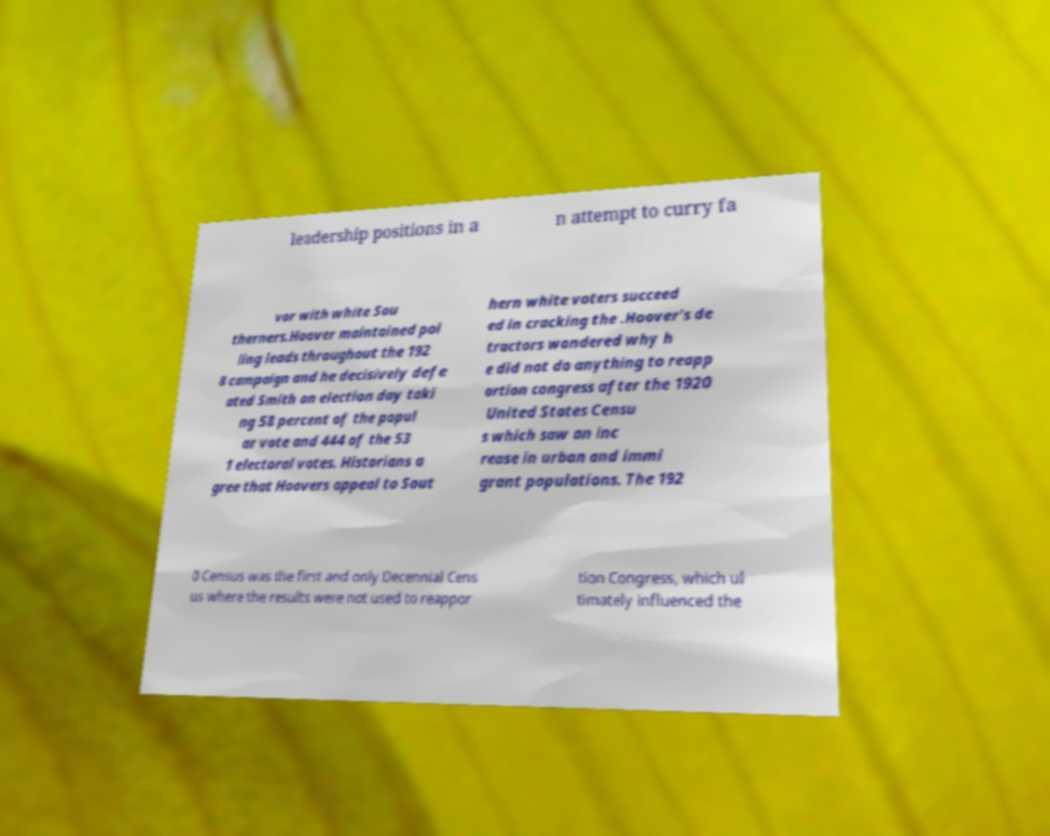Could you extract and type out the text from this image? leadership positions in a n attempt to curry fa vor with white Sou therners.Hoover maintained pol ling leads throughout the 192 8 campaign and he decisively defe ated Smith on election day taki ng 58 percent of the popul ar vote and 444 of the 53 1 electoral votes. Historians a gree that Hoovers appeal to Sout hern white voters succeed ed in cracking the .Hoover's de tractors wondered why h e did not do anything to reapp ortion congress after the 1920 United States Censu s which saw an inc rease in urban and immi grant populations. The 192 0 Census was the first and only Decennial Cens us where the results were not used to reappor tion Congress, which ul timately influenced the 